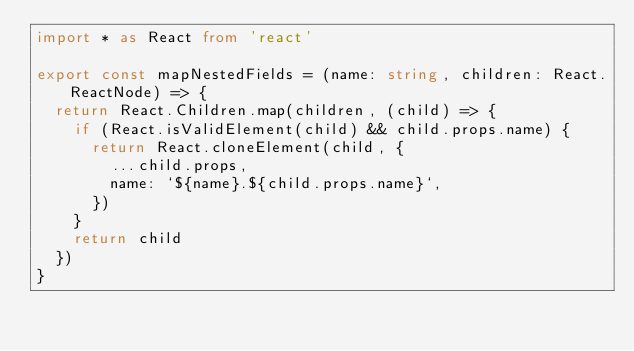<code> <loc_0><loc_0><loc_500><loc_500><_TypeScript_>import * as React from 'react'

export const mapNestedFields = (name: string, children: React.ReactNode) => {
  return React.Children.map(children, (child) => {
    if (React.isValidElement(child) && child.props.name) {
      return React.cloneElement(child, {
        ...child.props,
        name: `${name}.${child.props.name}`,
      })
    }
    return child
  })
}
</code> 